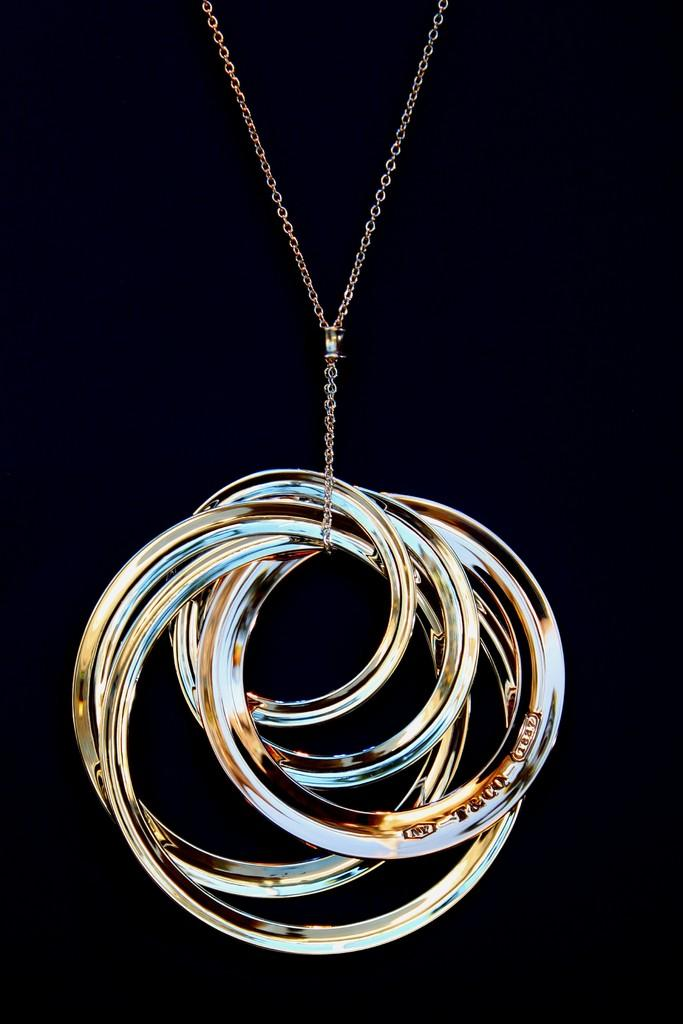What is the main object in the image? There is a chain in the image. How is the chain connected to other objects? The chain is tied to small rings. What color is the background of the image? The background of the image is black in color. Can you see a wave crashing on the shore in the image? There is no wave or shore present in the image; it features a chain tied to small rings with a black background. 